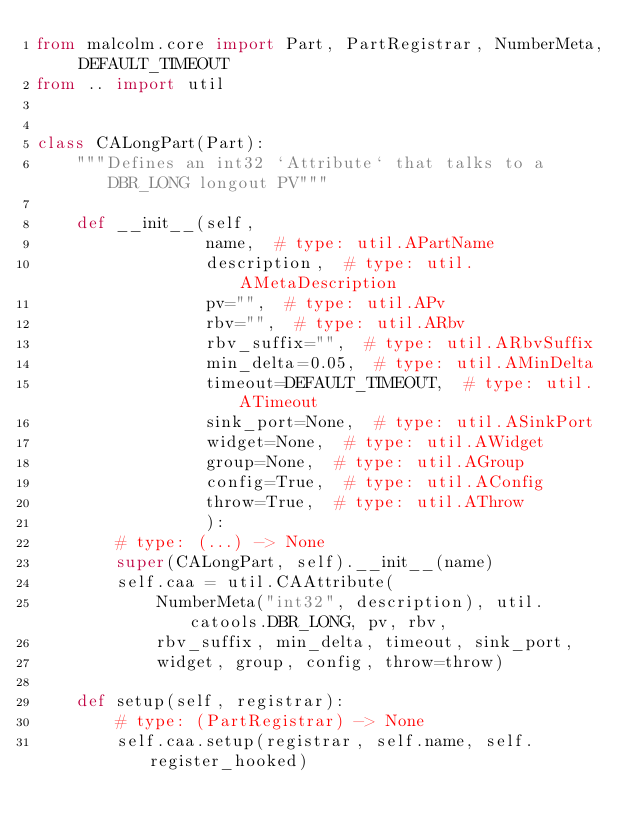Convert code to text. <code><loc_0><loc_0><loc_500><loc_500><_Python_>from malcolm.core import Part, PartRegistrar, NumberMeta, DEFAULT_TIMEOUT
from .. import util


class CALongPart(Part):
    """Defines an int32 `Attribute` that talks to a DBR_LONG longout PV"""

    def __init__(self,
                 name,  # type: util.APartName
                 description,  # type: util.AMetaDescription
                 pv="",  # type: util.APv
                 rbv="",  # type: util.ARbv
                 rbv_suffix="",  # type: util.ARbvSuffix
                 min_delta=0.05,  # type: util.AMinDelta
                 timeout=DEFAULT_TIMEOUT,  # type: util.ATimeout
                 sink_port=None,  # type: util.ASinkPort
                 widget=None,  # type: util.AWidget
                 group=None,  # type: util.AGroup
                 config=True,  # type: util.AConfig
                 throw=True,  # type: util.AThrow
                 ):
        # type: (...) -> None
        super(CALongPart, self).__init__(name)
        self.caa = util.CAAttribute(
            NumberMeta("int32", description), util.catools.DBR_LONG, pv, rbv,
            rbv_suffix, min_delta, timeout, sink_port,
            widget, group, config, throw=throw)

    def setup(self, registrar):
        # type: (PartRegistrar) -> None
        self.caa.setup(registrar, self.name, self.register_hooked)

</code> 